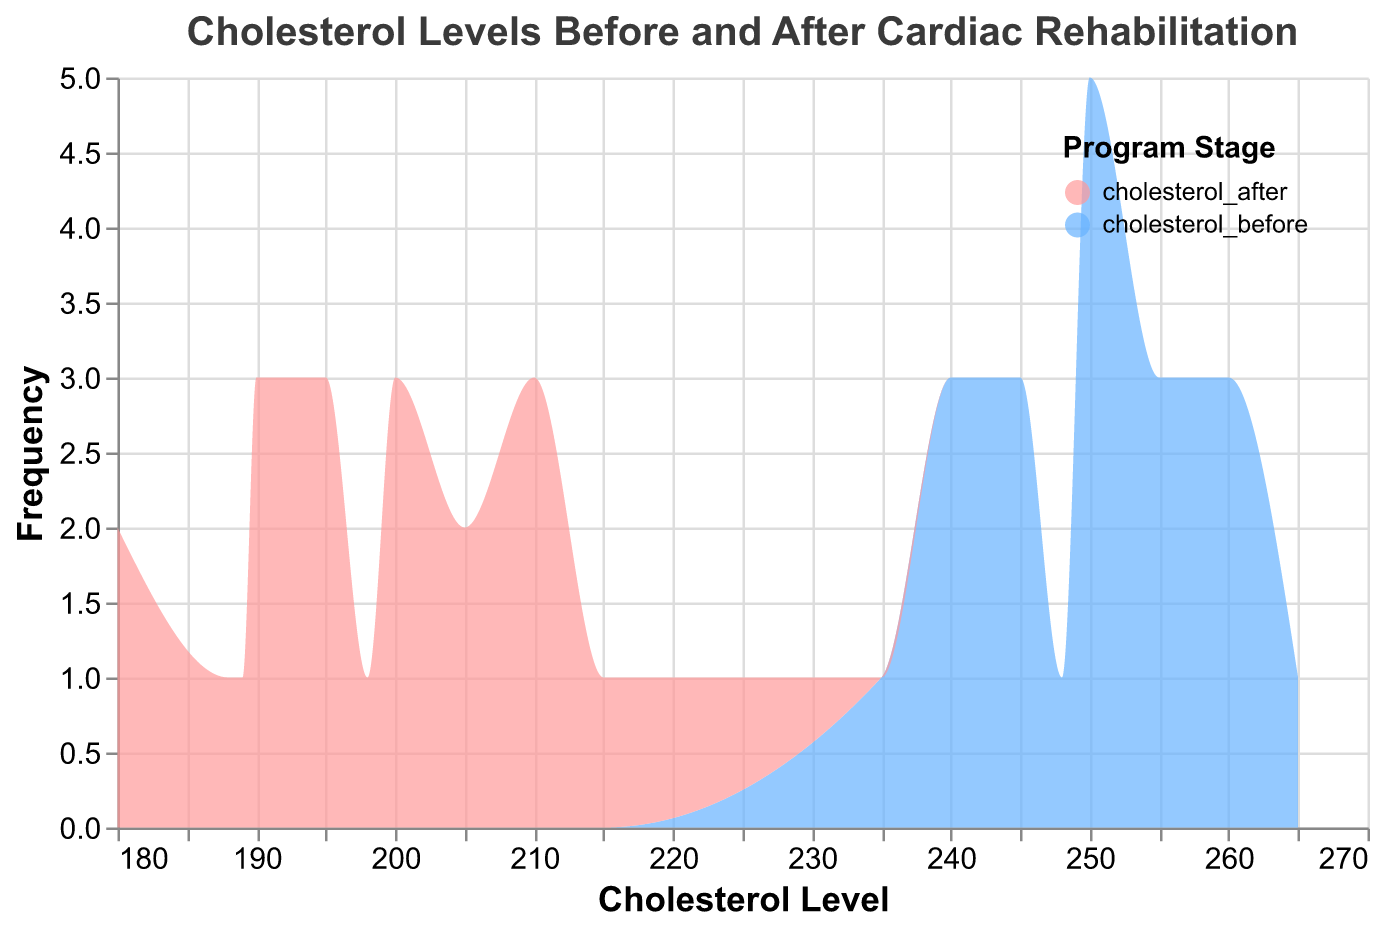What does the title of the figure suggest about the data being visualized? The title "Cholesterol Levels Before and After Cardiac Rehabilitation" suggests that the figure visualizes cholesterol levels of participants both before and after they underwent a cardiac rehabilitation program.
Answer: Cholesterol levels before and after cardiac rehabilitation What is the range of cholesterol levels before starting the cardiac rehabilitation program? To find the range, identify the minimum and maximum cholesterol levels in the "cholesterol_before" category. From the data, the minimum value is 235 and the maximum value is 265.
Answer: 235 to 265 Which stage has a higher frequency of participants at the cholesterol level 250? From the figure, look for the height of the area chart at cholesterol level 250 for both "cholesterol_before" and "cholesterol_after". Compare the heights to determine which is higher.
Answer: Cholesterol_before What is the difference in the peak frequency of participants between the before and after stages? Identify the peaks in the frequency for both "cholesterol_before" and "cholesterol_after". Subtract the peak frequency of the "after" stage from the "before" stage. Assume peak frequencies are at 250 for "before" and 195 for "after" from the area chart. Suppose the frequencies at these points are 5 for "before" and 4 for "after", then the difference is 5 - 4.
Answer: 1 Is there a more uniform distribution of cholesterol levels before or after the rehabilitation program? A more uniform distribution would look flatter and more spread out. Examine the area graphs for "cholesterol_before" and "cholesterol_after" to see which one appears more evenly distributed.
Answer: Cholesterol_after What is the highest cholesterol value after the rehabilitation program? From the data, identify the highest value in the "cholesterol_after" category. The data shows 215 as the highest value.
Answer: 215 How many participants reduced their cholesterol levels to below 200 after the rehabilitation program? Count the number of participants where "cholesterol_after" is below 200 by reviewing the data. From the data, participants are: Alice, Grace, Isaac, Katherine, Mia, Noah, Olivia, Quinn, Rachel, Tina.
Answer: 10 What is the median cholesterol level before starting the rehabilitation program? Arrange the "cholesterol_before" values in ascending order and find the middle value. The ordered values are 235, 240, 240, 240, 245, 245, 245, 245, 248, 250, 250, 250, 250, 250, 255, 255, 255, 260, 260, 260, 265. The middle value in this ordered list is 250.
Answer: 250 Is the average cholesterol level lower after the rehabilitation program compared to before? Calculate the average cholesterol levels for "cholesterol_before" and "cholesterol_after". For "cholesterol_before": (240+260+250+245+235+250+248+255+240+260+245+255+250+240+265+250+245+250+260+255)/20 ≈ 250.75. For "cholesterol_after": (190+210+200+195+180+215+198+210+189+205+190+195+188+180+200+210+190+200+205+195)/20 ≈ 197.
Answer: Yes What can be inferred about overall cholesterol level changes due to the rehabilitation program? Compare the aggregate frequencies and spread of cholesterol values before and after. Generally, there are more participants with higher cholesterol levels before the program and lower cholesterol levels after, indicating improvement.
Answer: Cholesterol levels improved 